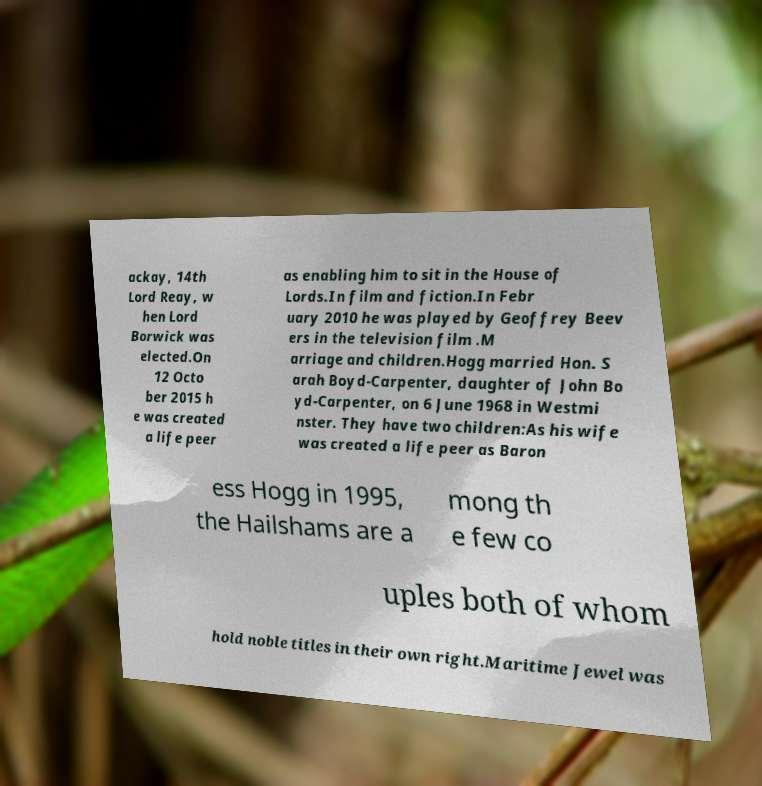What messages or text are displayed in this image? I need them in a readable, typed format. ackay, 14th Lord Reay, w hen Lord Borwick was elected.On 12 Octo ber 2015 h e was created a life peer as enabling him to sit in the House of Lords.In film and fiction.In Febr uary 2010 he was played by Geoffrey Beev ers in the television film .M arriage and children.Hogg married Hon. S arah Boyd-Carpenter, daughter of John Bo yd-Carpenter, on 6 June 1968 in Westmi nster. They have two children:As his wife was created a life peer as Baron ess Hogg in 1995, the Hailshams are a mong th e few co uples both of whom hold noble titles in their own right.Maritime Jewel was 